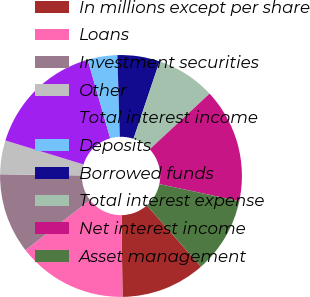<chart> <loc_0><loc_0><loc_500><loc_500><pie_chart><fcel>In millions except per share<fcel>Loans<fcel>Investment securities<fcel>Other<fcel>Total interest income<fcel>Deposits<fcel>Borrowed funds<fcel>Total interest expense<fcel>Net interest income<fcel>Asset management<nl><fcel>11.3%<fcel>14.69%<fcel>10.73%<fcel>4.52%<fcel>15.82%<fcel>3.96%<fcel>5.65%<fcel>7.91%<fcel>15.25%<fcel>10.17%<nl></chart> 